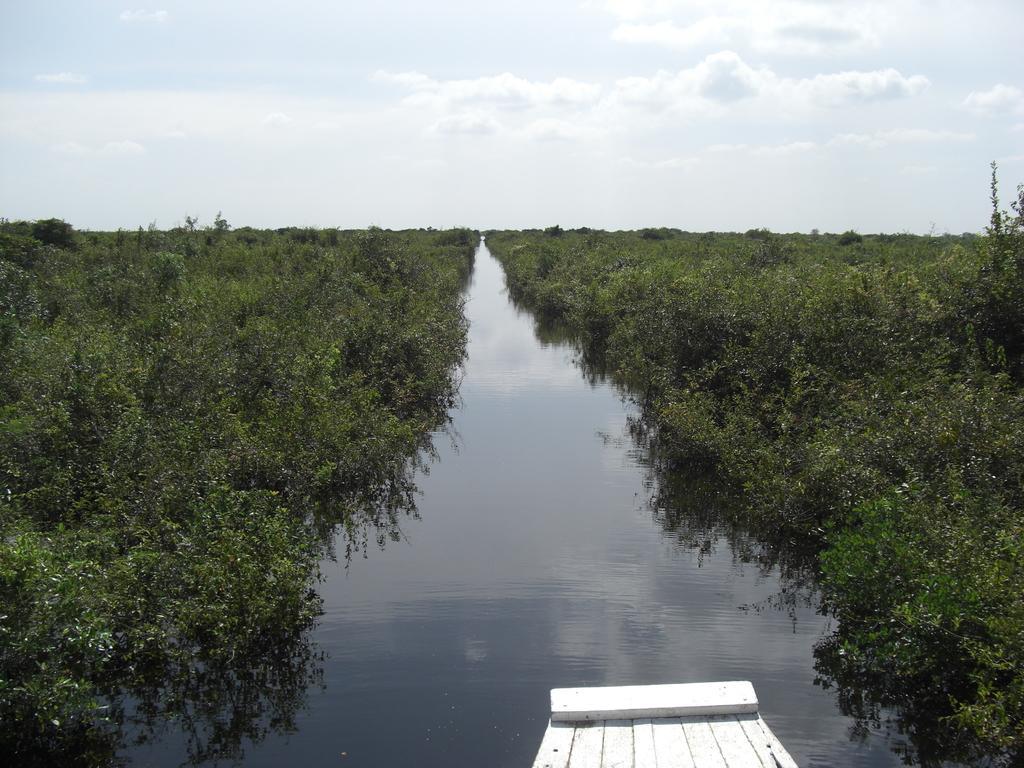How would you summarize this image in a sentence or two? In this image I can see the water, background I can see the trees in green color and the sky is in white color. 